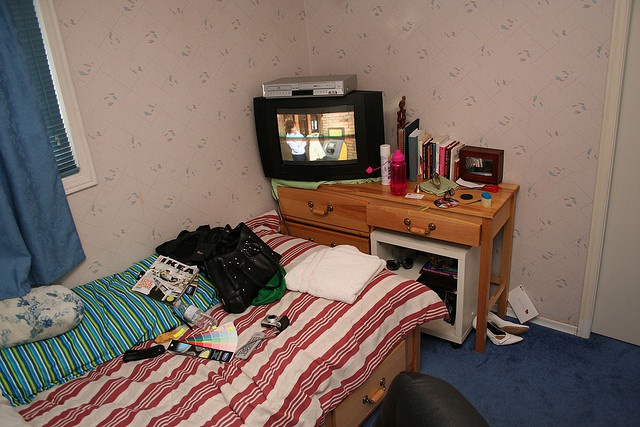Describe the objects in this image and their specific colors. I can see bed in darkblue, darkgray, tan, maroon, and brown tones, tv in darkblue, black, gray, and ivory tones, handbag in darkblue, black, gray, maroon, and darkgray tones, book in darkblue, darkgray, black, and gray tones, and book in darkblue, black, lightgray, tan, and lightpink tones in this image. 